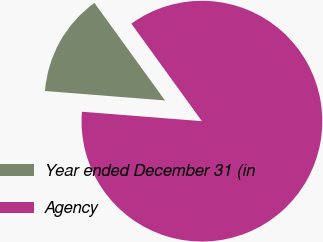Convert chart to OTSL. <chart><loc_0><loc_0><loc_500><loc_500><pie_chart><fcel>Year ended December 31 (in<fcel>Agency<nl><fcel>13.78%<fcel>86.22%<nl></chart> 